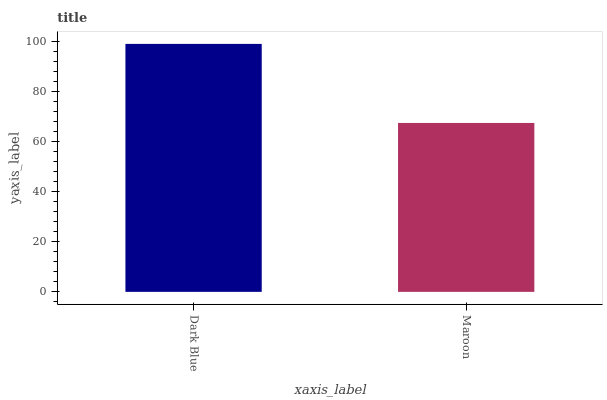Is Maroon the maximum?
Answer yes or no. No. Is Dark Blue greater than Maroon?
Answer yes or no. Yes. Is Maroon less than Dark Blue?
Answer yes or no. Yes. Is Maroon greater than Dark Blue?
Answer yes or no. No. Is Dark Blue less than Maroon?
Answer yes or no. No. Is Dark Blue the high median?
Answer yes or no. Yes. Is Maroon the low median?
Answer yes or no. Yes. Is Maroon the high median?
Answer yes or no. No. Is Dark Blue the low median?
Answer yes or no. No. 